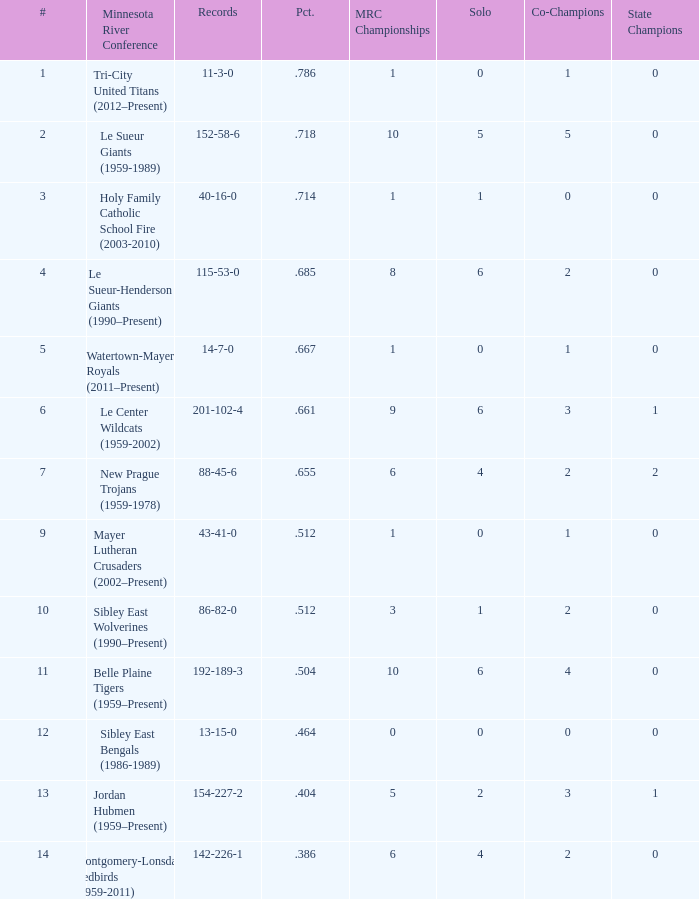What are the record(s) for the team with a triumph proportion of .464? 13-15-0. 